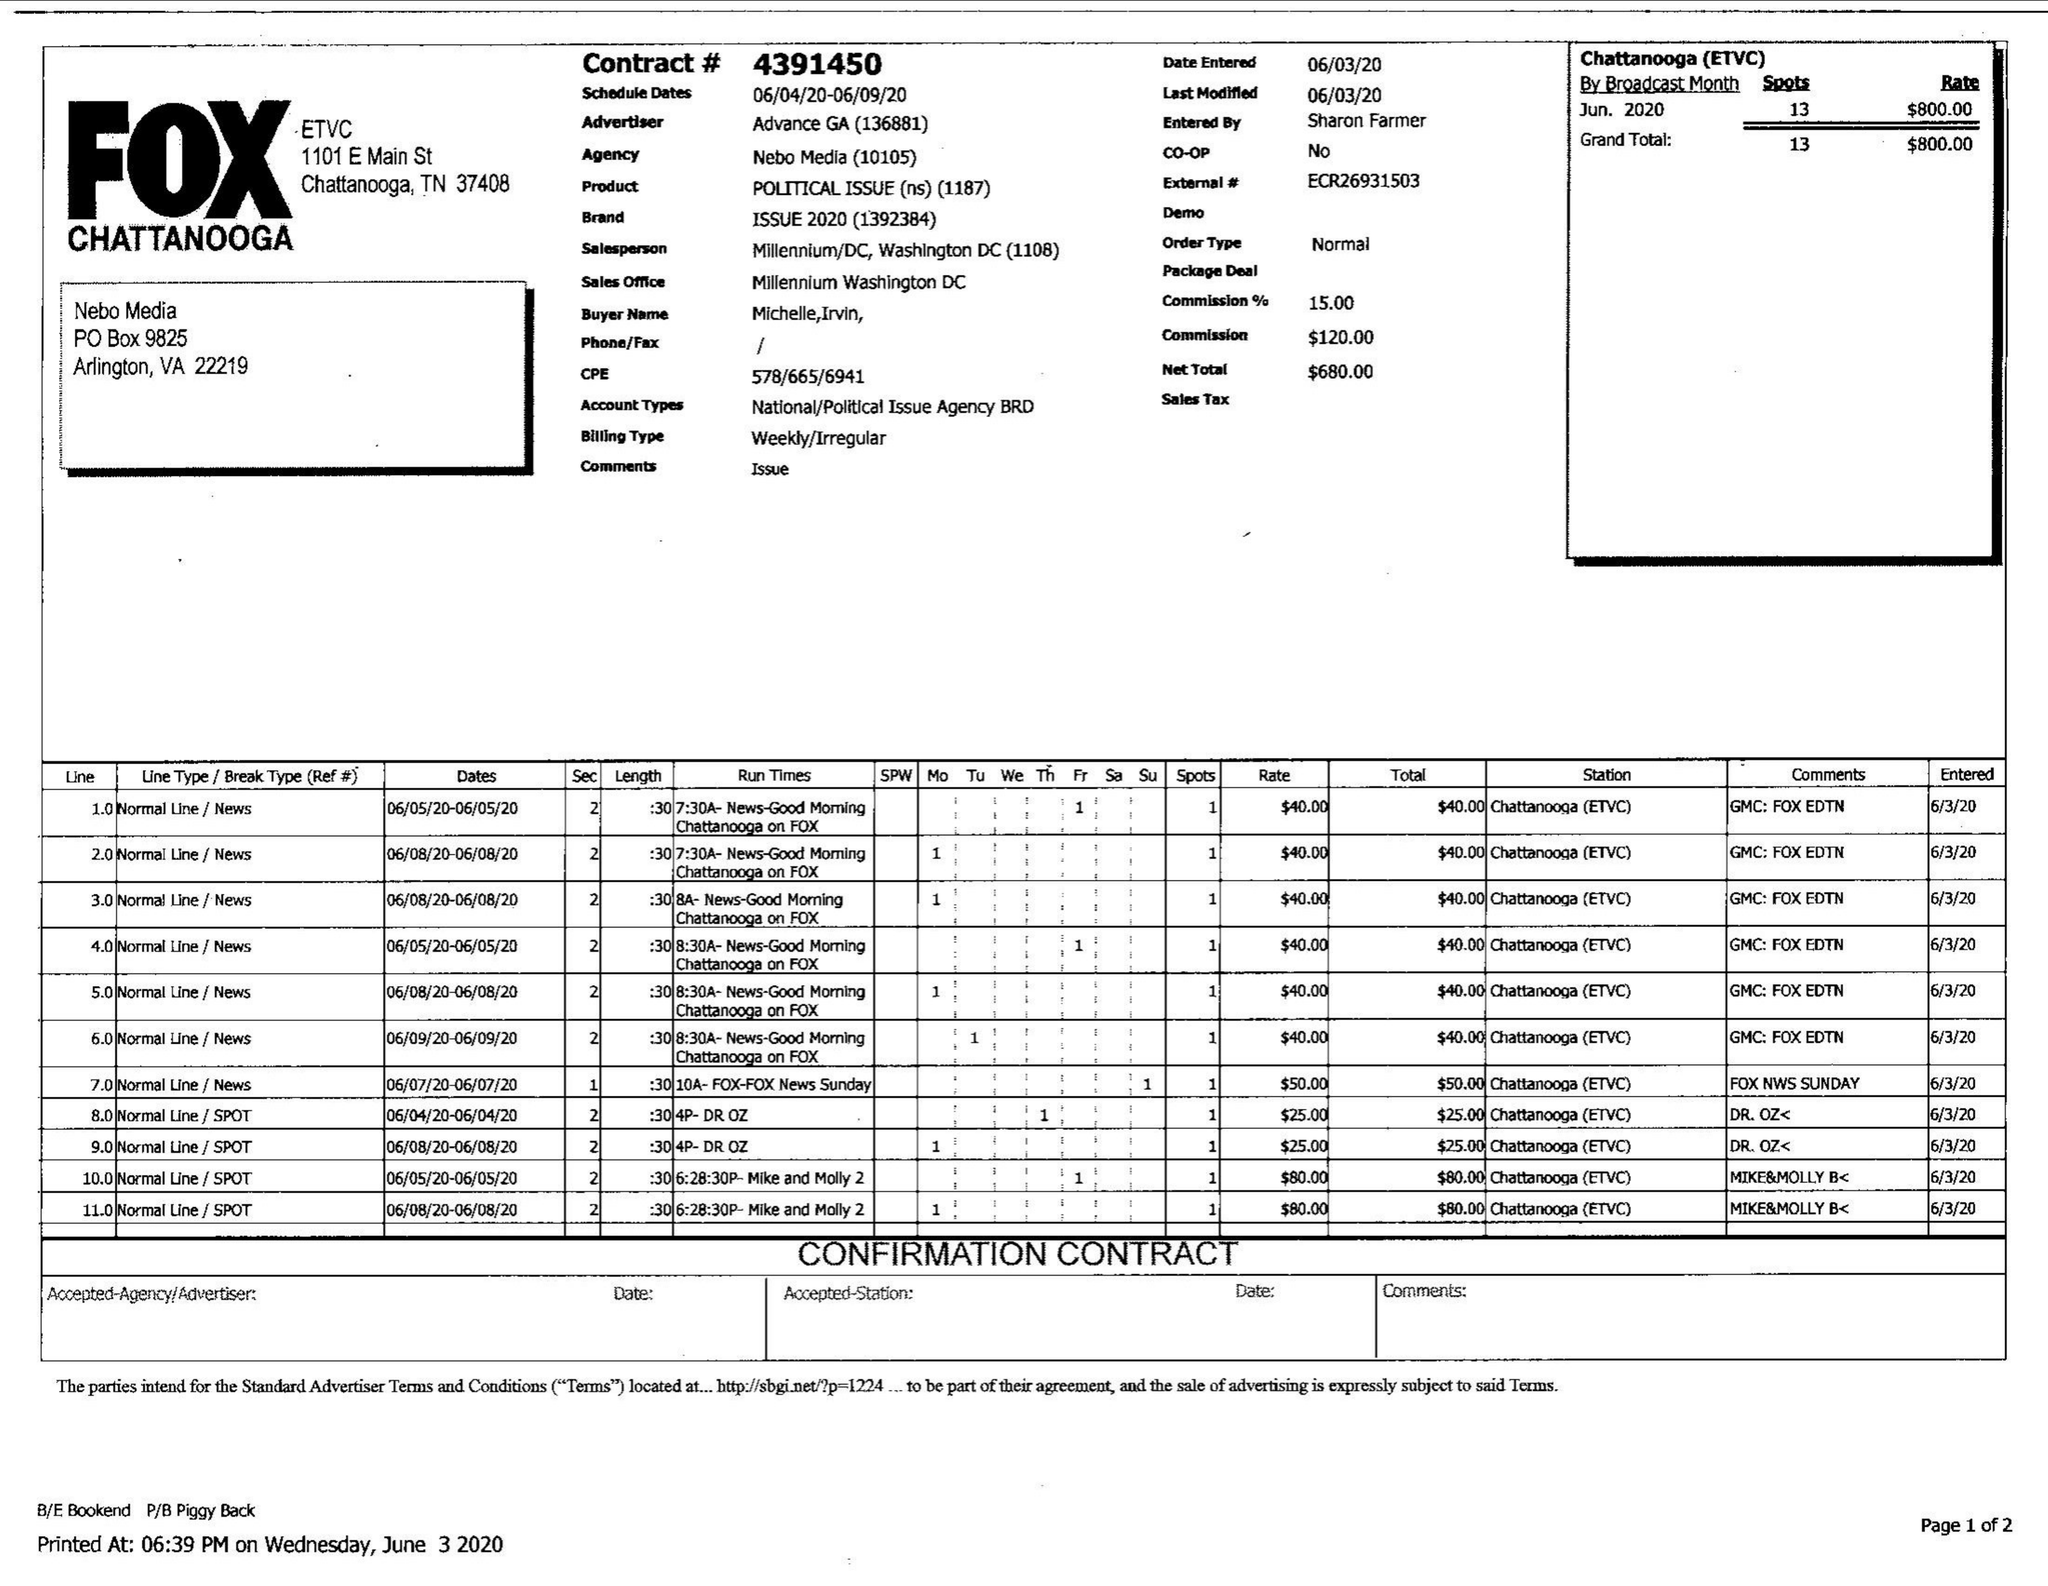What is the value for the contract_num?
Answer the question using a single word or phrase. 4391450 